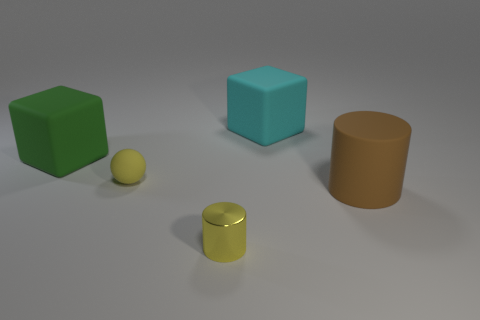Add 1 small yellow objects. How many objects exist? 6 Subtract all yellow cylinders. How many yellow blocks are left? 0 Subtract all small red cubes. Subtract all shiny objects. How many objects are left? 4 Add 2 large cyan rubber objects. How many large cyan rubber objects are left? 3 Add 2 tiny objects. How many tiny objects exist? 4 Subtract all green blocks. How many blocks are left? 1 Subtract 1 cyan cubes. How many objects are left? 4 Subtract all cubes. How many objects are left? 3 Subtract all cyan balls. Subtract all yellow blocks. How many balls are left? 1 